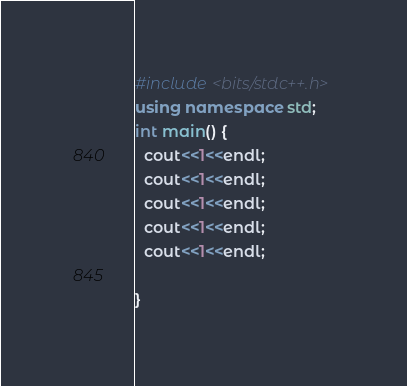Convert code to text. <code><loc_0><loc_0><loc_500><loc_500><_C++_>#include <bits/stdc++.h>
using namespace std;
int main() {
  cout<<1<<endl;
  cout<<1<<endl;
  cout<<1<<endl;
  cout<<1<<endl;
  cout<<1<<endl;
  
}</code> 